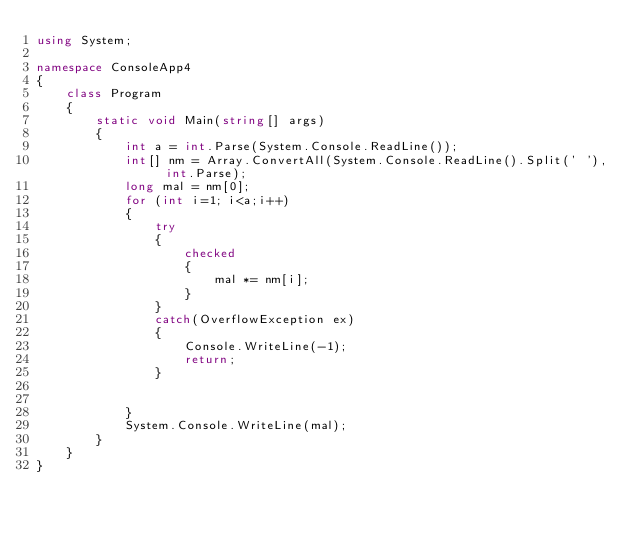<code> <loc_0><loc_0><loc_500><loc_500><_C#_>using System;

namespace ConsoleApp4
{
    class Program
    {
        static void Main(string[] args)
        {
            int a = int.Parse(System.Console.ReadLine());
            int[] nm = Array.ConvertAll(System.Console.ReadLine().Split(' '), int.Parse);
            long mal = nm[0];
            for (int i=1; i<a;i++)
            {  
                try
                {
                    checked
                    {
                        mal *= nm[i];
                    }
                }
                catch(OverflowException ex)
                {
                    Console.WriteLine(-1);
                    return;
                }
                

            }
            System.Console.WriteLine(mal);
        }
    }
}
</code> 